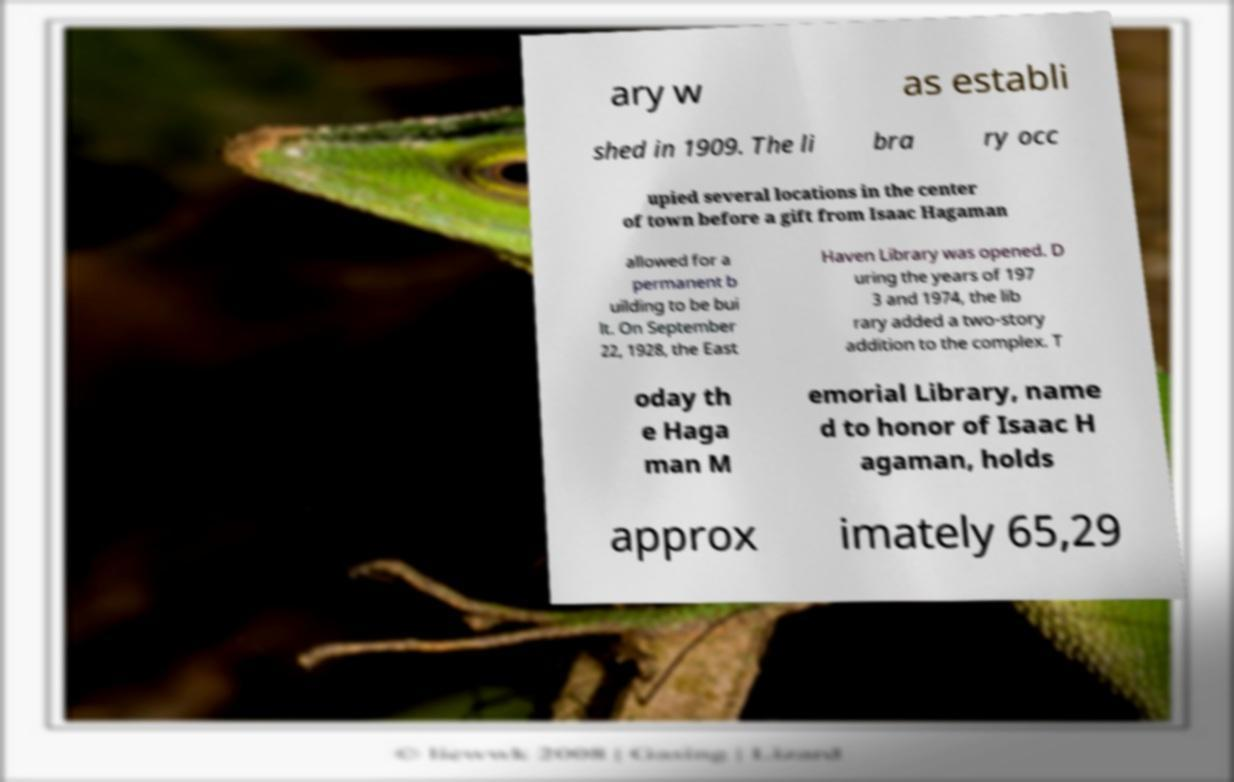There's text embedded in this image that I need extracted. Can you transcribe it verbatim? ary w as establi shed in 1909. The li bra ry occ upied several locations in the center of town before a gift from Isaac Hagaman allowed for a permanent b uilding to be bui lt. On September 22, 1928, the East Haven Library was opened. D uring the years of 197 3 and 1974, the lib rary added a two-story addition to the complex. T oday th e Haga man M emorial Library, name d to honor of Isaac H agaman, holds approx imately 65,29 